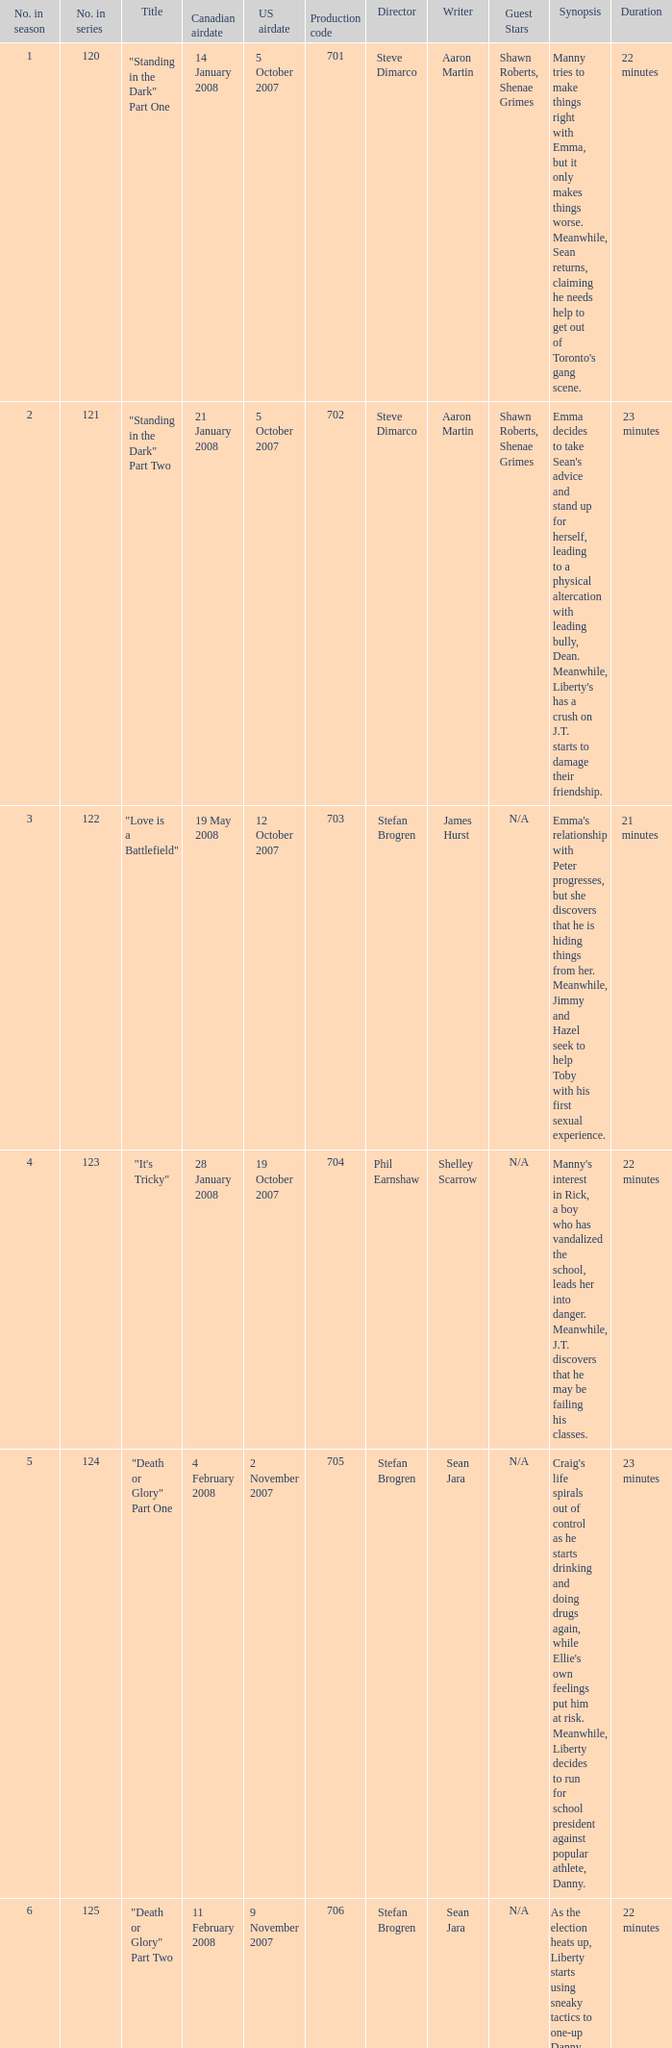The canadian airdate of 11 february 2008 applied to what series number? 1.0. 